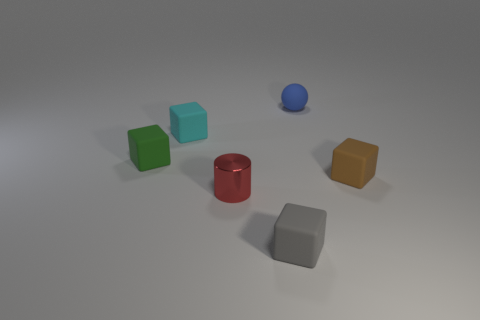Is there a small purple ball made of the same material as the tiny cyan cube?
Ensure brevity in your answer.  No. The tiny matte sphere is what color?
Offer a very short reply. Blue. There is a object on the left side of the small cyan cube; what is its size?
Your answer should be very brief. Small. What number of matte spheres have the same color as the cylinder?
Give a very brief answer. 0. There is a tiny rubber cube that is behind the small green object; are there any tiny green cubes that are in front of it?
Keep it short and to the point. Yes. There is a matte sphere that is to the right of the cyan rubber block; is its color the same as the block that is in front of the brown rubber block?
Your response must be concise. No. What is the color of the sphere that is the same size as the metal cylinder?
Give a very brief answer. Blue. Are there an equal number of tiny red metallic cylinders behind the green thing and small blue things in front of the metal cylinder?
Offer a terse response. Yes. What is the tiny cube that is behind the thing to the left of the tiny cyan cube made of?
Provide a short and direct response. Rubber. What number of objects are either big red rubber spheres or small cyan cubes?
Your answer should be very brief. 1. 